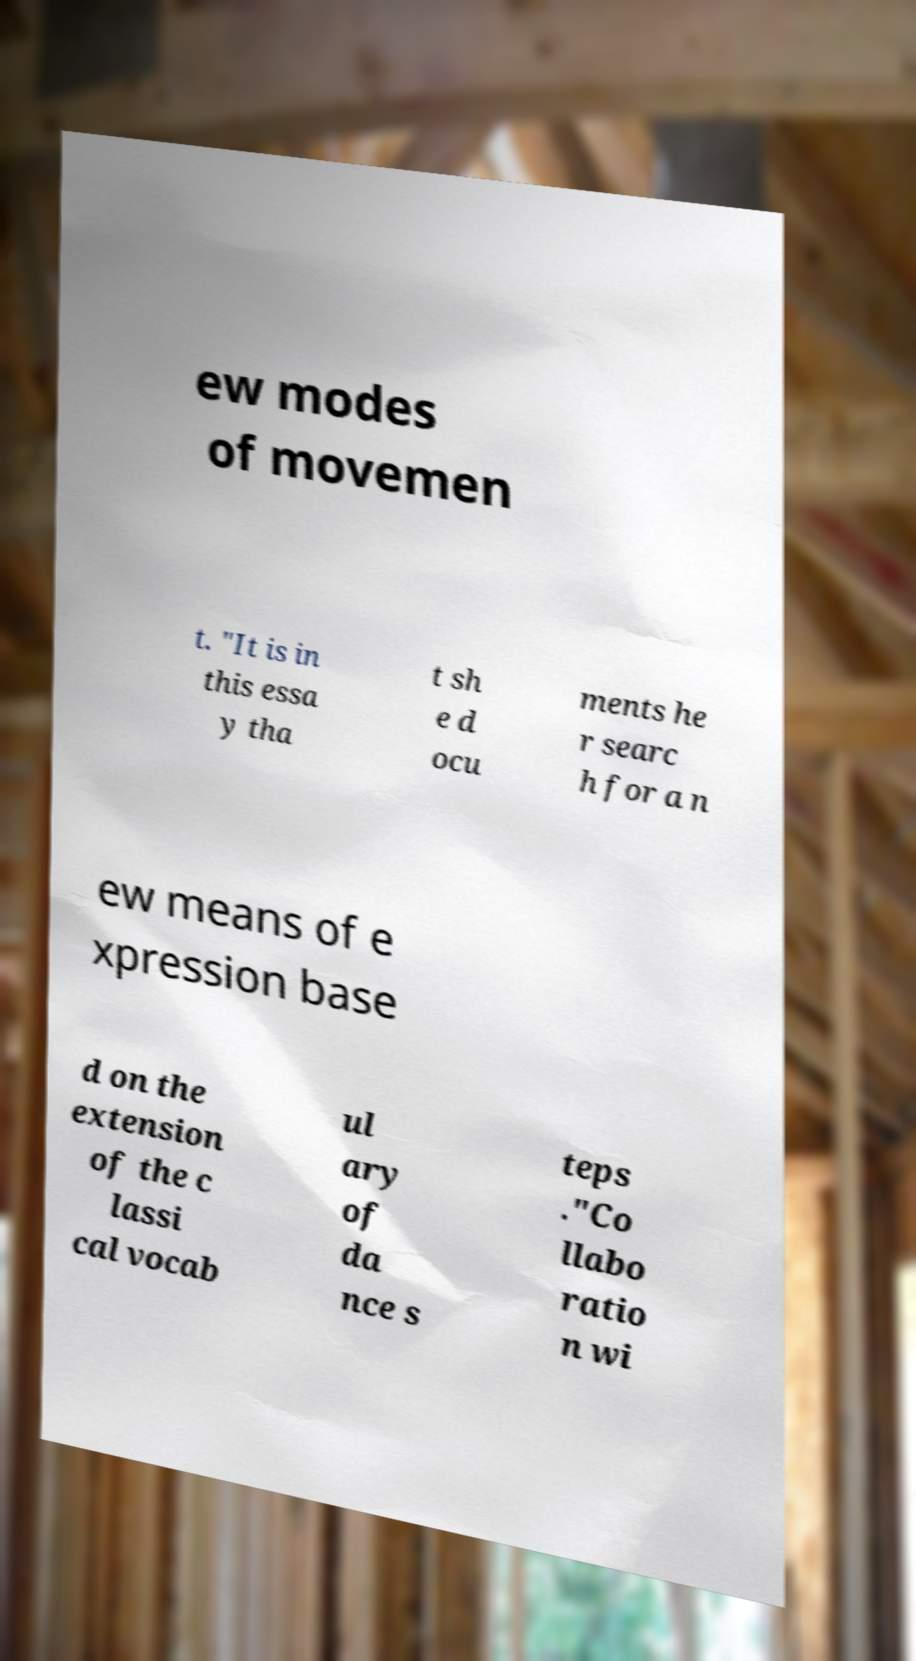Can you accurately transcribe the text from the provided image for me? ew modes of movemen t. "It is in this essa y tha t sh e d ocu ments he r searc h for a n ew means of e xpression base d on the extension of the c lassi cal vocab ul ary of da nce s teps ."Co llabo ratio n wi 